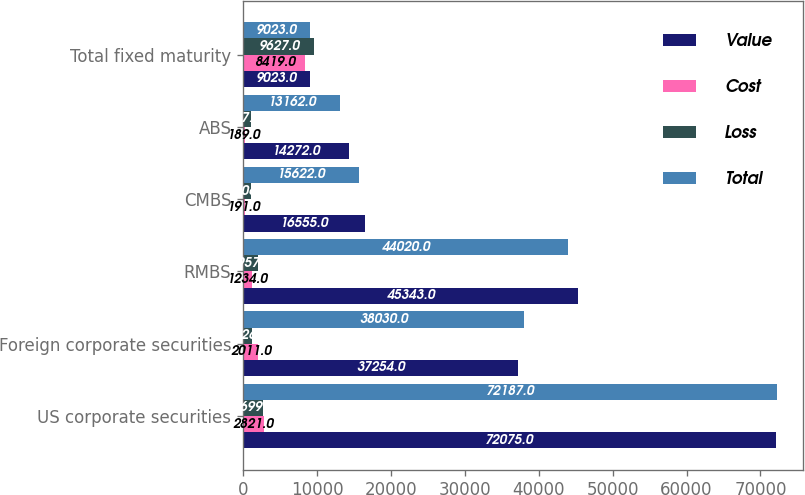Convert chart to OTSL. <chart><loc_0><loc_0><loc_500><loc_500><stacked_bar_chart><ecel><fcel>US corporate securities<fcel>Foreign corporate securities<fcel>RMBS<fcel>CMBS<fcel>ABS<fcel>Total fixed maturity<nl><fcel>Value<fcel>72075<fcel>37254<fcel>45343<fcel>16555<fcel>14272<fcel>9023<nl><fcel>Cost<fcel>2821<fcel>2011<fcel>1234<fcel>191<fcel>189<fcel>8419<nl><fcel>Loss<fcel>2699<fcel>1226<fcel>1957<fcel>1106<fcel>1077<fcel>9627<nl><fcel>Total<fcel>72187<fcel>38030<fcel>44020<fcel>15622<fcel>13162<fcel>9023<nl></chart> 